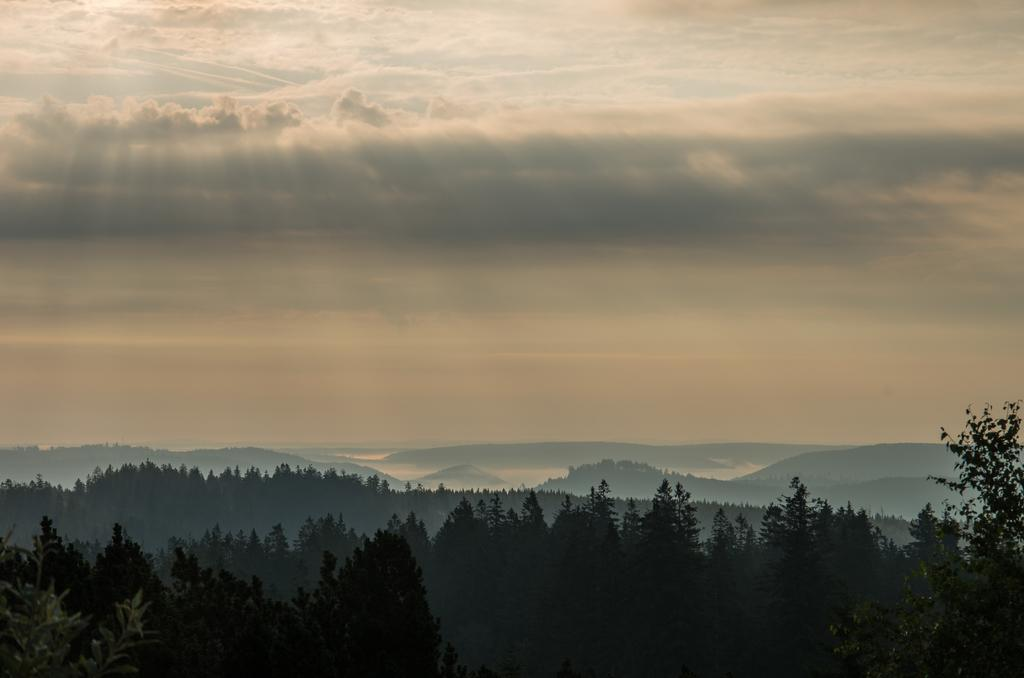What type of vegetation can be seen in the image? There are trees in the image. What can be seen in the background of the image? There are hills visible in the background of the image. What part of the natural environment is visible in the image? The sky is visible in the image. What is present in the sky? Clouds are present in the sky. What type of oatmeal is being served in the image? There is no oatmeal present in the image. What time of day is depicted in the image? The provided facts do not give any information about the time of day, so it cannot be determined from the image. 